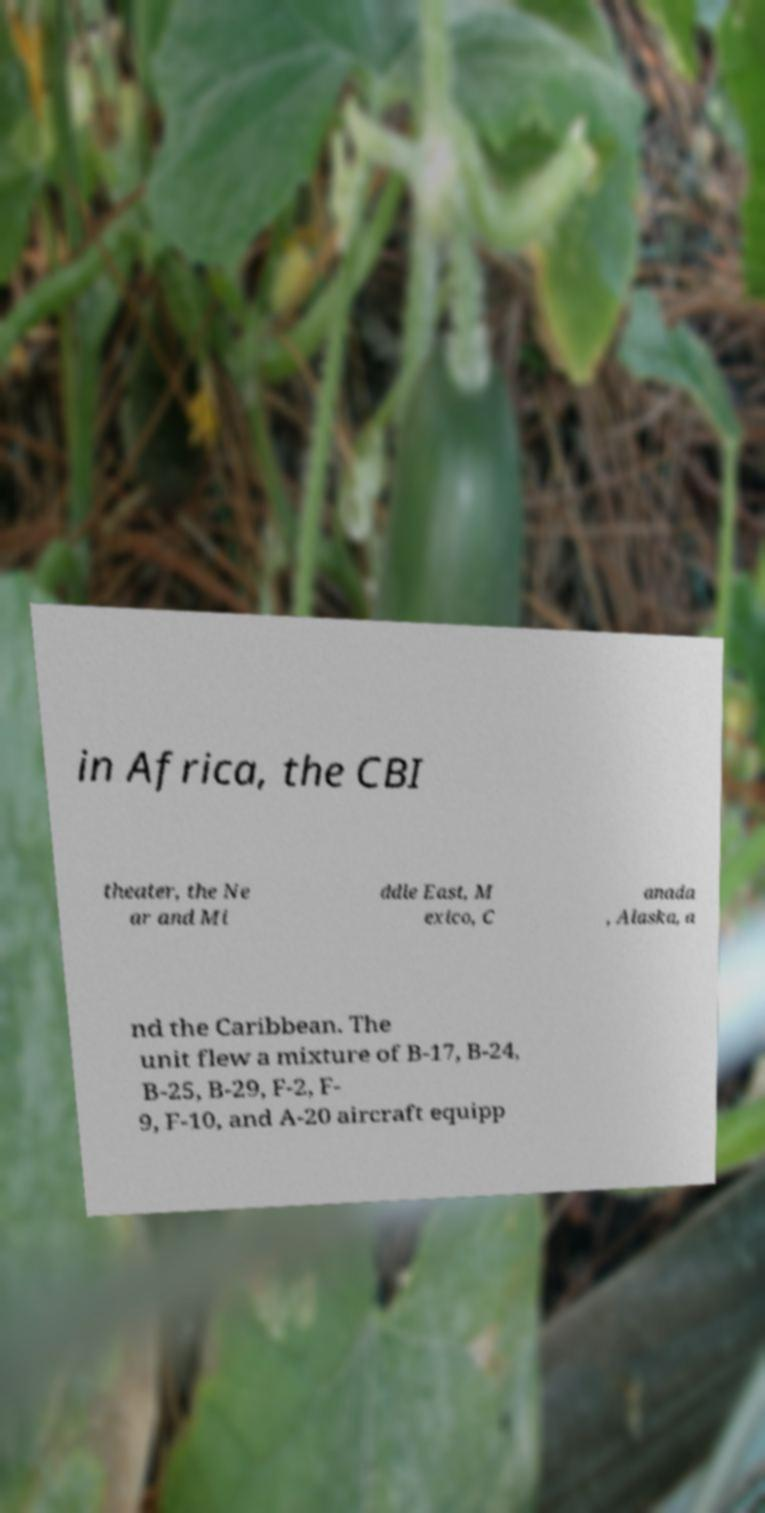Could you assist in decoding the text presented in this image and type it out clearly? in Africa, the CBI theater, the Ne ar and Mi ddle East, M exico, C anada , Alaska, a nd the Caribbean. The unit flew a mixture of B-17, B-24, B-25, B-29, F-2, F- 9, F-10, and A-20 aircraft equipp 